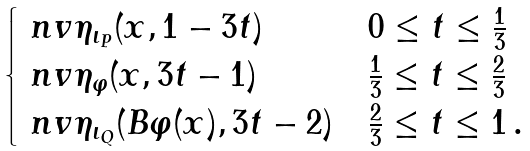<formula> <loc_0><loc_0><loc_500><loc_500>\begin{cases} \ n v { \eta _ { \iota _ { P } } } ( x , 1 - 3 t ) & 0 \leq t \leq \frac { 1 } { 3 } \\ \ n v { \eta _ { \varphi } } ( x , 3 t - 1 ) & \frac { 1 } { 3 } \leq t \leq \frac { 2 } { 3 } \\ \ n v { \eta _ { \iota _ { Q } } } ( B \varphi ( x ) , 3 t - 2 ) & \frac { 2 } { 3 } \leq t \leq 1 \, . \end{cases}</formula> 